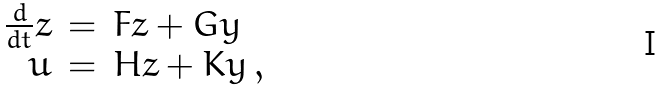Convert formula to latex. <formula><loc_0><loc_0><loc_500><loc_500>\begin{array} { r c l } \frac { d } { d t } { z } & = & F { z } + G { y } \\ { u } & = & H { z } + K { y } \, , \end{array}</formula> 